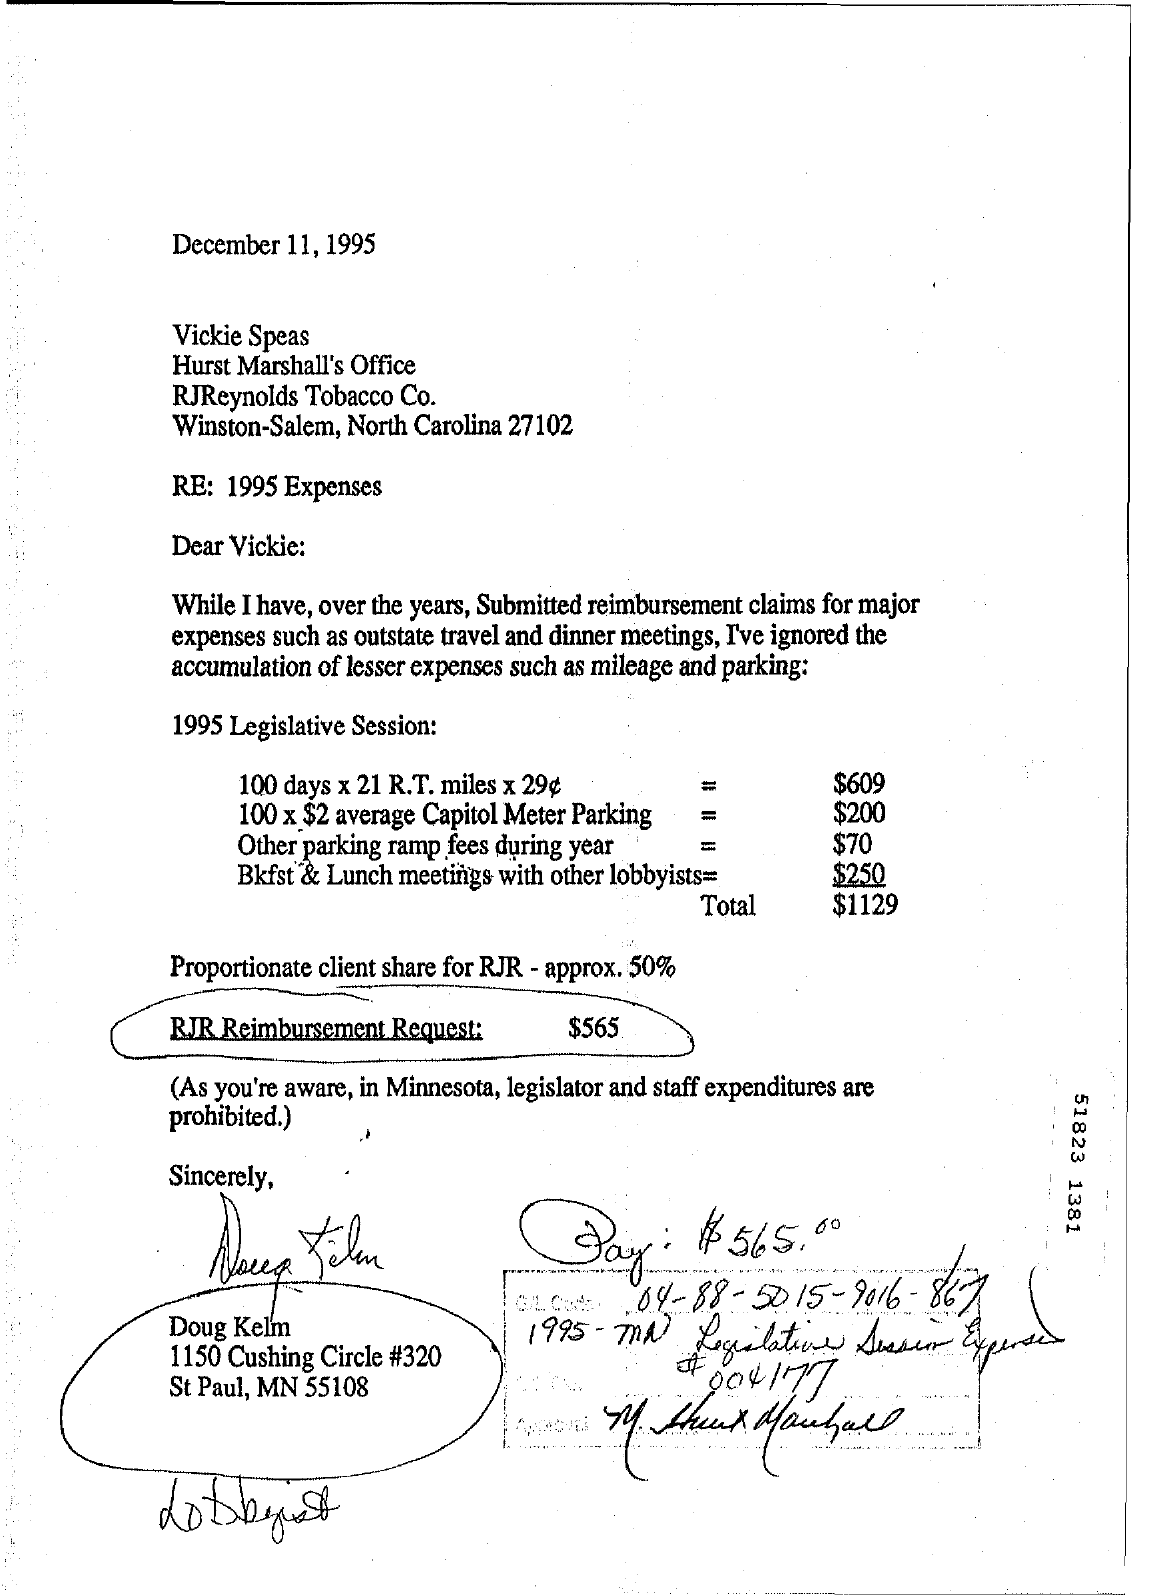Mention a couple of crucial points in this snapshot. The RJR Reimbursement Request is $565. The letter is from Doug Kelm. The letter is dated December 11, 1995. The letter is addressed to Vickie Speas. 